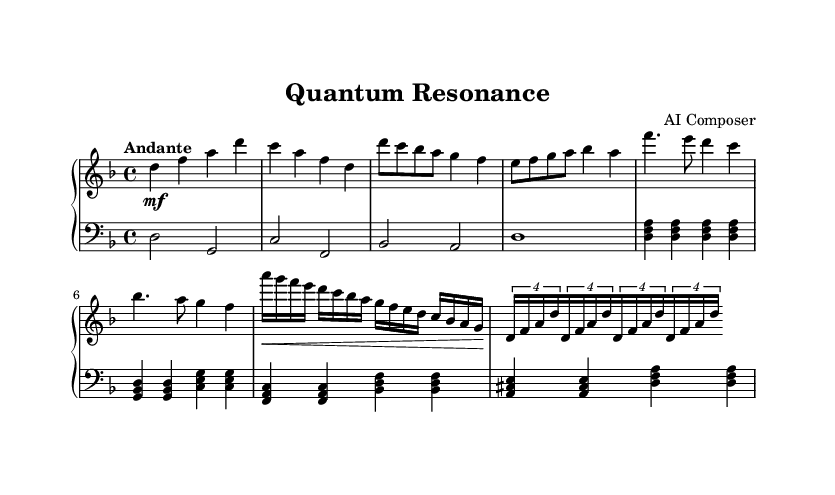What is the key signature of this music? The key signature is indicated at the beginning of the staff, showing two flats (B♭ and E♭), which defines D minor as the key.
Answer: D minor What is the time signature of this piece? The time signature, which indicates the rhythmic structure of the piece, is shown at the beginning as 4/4. This means there are four beats per measure, and the quarter note gets one beat.
Answer: 4/4 What is the tempo marking of this composition? The tempo marking is written as "Andante," indicating a moderately slow tempo, typically a walking pace. This guides performers on how quickly to play the piece.
Answer: Andante How many measures are there in the introduction section? The introduction section consists of four measures, as the notes listed at the start indicate four distinct musical phrases before the themes begin.
Answer: 4 Which musical themes are presented in the piece? The piece introduces two distinct themes labeled as Theme A and Theme B. Theme A is characterized by the rising melodic line, while Theme B follows with a rhythmic pattern.
Answer: Theme A, Theme B In which octave does the right hand primarily play? The right hand primarily plays in the octave that includes notes starting from D (the lowest note) in the second octave to A (the highest note) in the fourth octave, which is indicated by the relative notation used.
Answer: Second to fourth octave What is the overall dynamic marking of the piece? The piece has a medium dynamic marking (mf) at the introduction, suggesting a moderately loud volume throughout. This influences the emotional intensity of the performance.
Answer: mf 